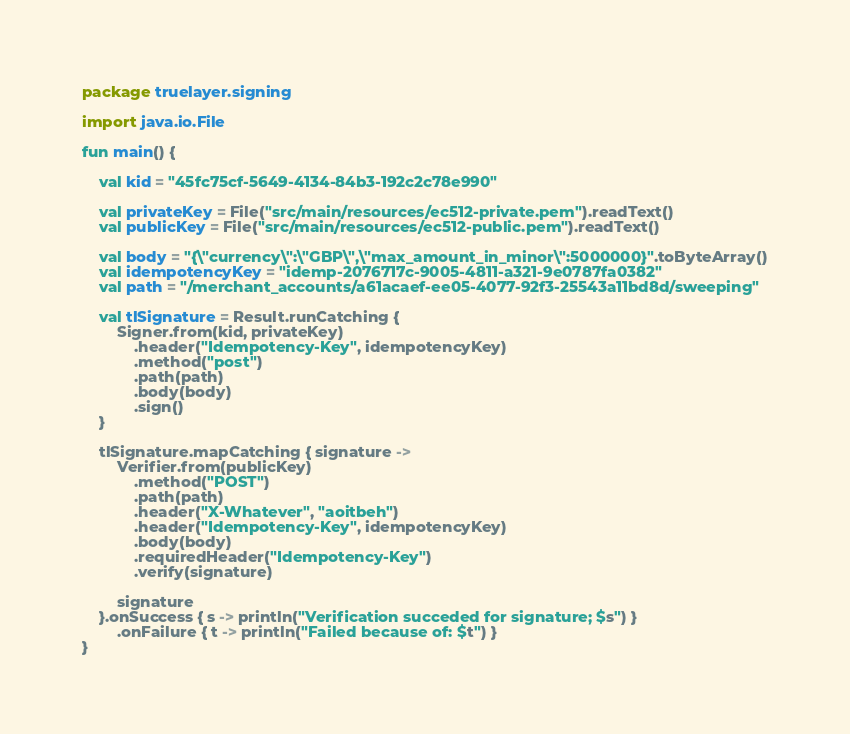<code> <loc_0><loc_0><loc_500><loc_500><_Kotlin_>package truelayer.signing

import java.io.File

fun main() {

    val kid = "45fc75cf-5649-4134-84b3-192c2c78e990"

    val privateKey = File("src/main/resources/ec512-private.pem").readText()
    val publicKey = File("src/main/resources/ec512-public.pem").readText()

    val body = "{\"currency\":\"GBP\",\"max_amount_in_minor\":5000000}".toByteArray()
    val idempotencyKey = "idemp-2076717c-9005-4811-a321-9e0787fa0382"
    val path = "/merchant_accounts/a61acaef-ee05-4077-92f3-25543a11bd8d/sweeping"

    val tlSignature = Result.runCatching {
        Signer.from(kid, privateKey)
            .header("Idempotency-Key", idempotencyKey)
            .method("post")
            .path(path)
            .body(body)
            .sign()
    }

    tlSignature.mapCatching { signature ->
        Verifier.from(publicKey)
            .method("POST")
            .path(path)
            .header("X-Whatever", "aoitbeh")
            .header("Idempotency-Key", idempotencyKey)
            .body(body)
            .requiredHeader("Idempotency-Key")
            .verify(signature)

        signature
    }.onSuccess { s -> println("Verification succeded for signature; $s") }
        .onFailure { t -> println("Failed because of: $t") }
}</code> 